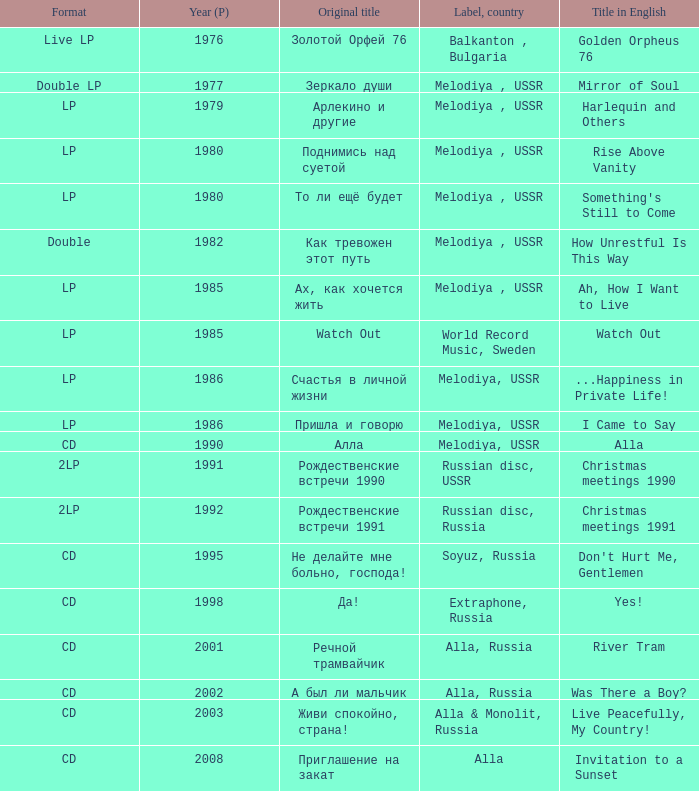What is the english title with a lp format and an Original title of то ли ещё будет? Something's Still to Come. 